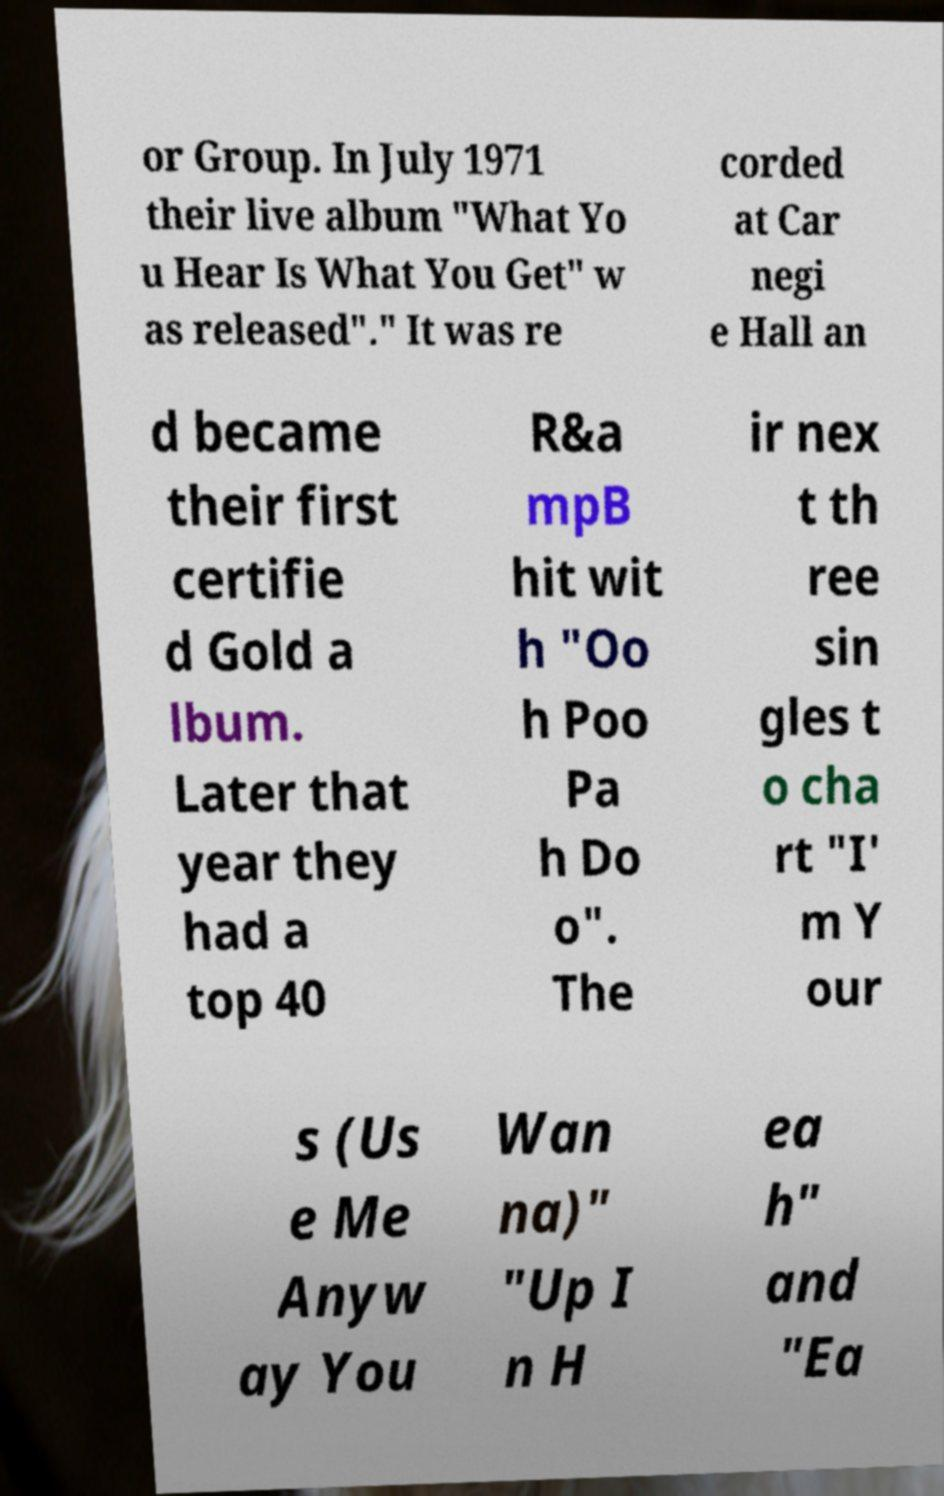Could you extract and type out the text from this image? or Group. In July 1971 their live album "What Yo u Hear Is What You Get" w as released"." It was re corded at Car negi e Hall an d became their first certifie d Gold a lbum. Later that year they had a top 40 R&a mpB hit wit h "Oo h Poo Pa h Do o". The ir nex t th ree sin gles t o cha rt "I' m Y our s (Us e Me Anyw ay You Wan na)" "Up I n H ea h" and "Ea 